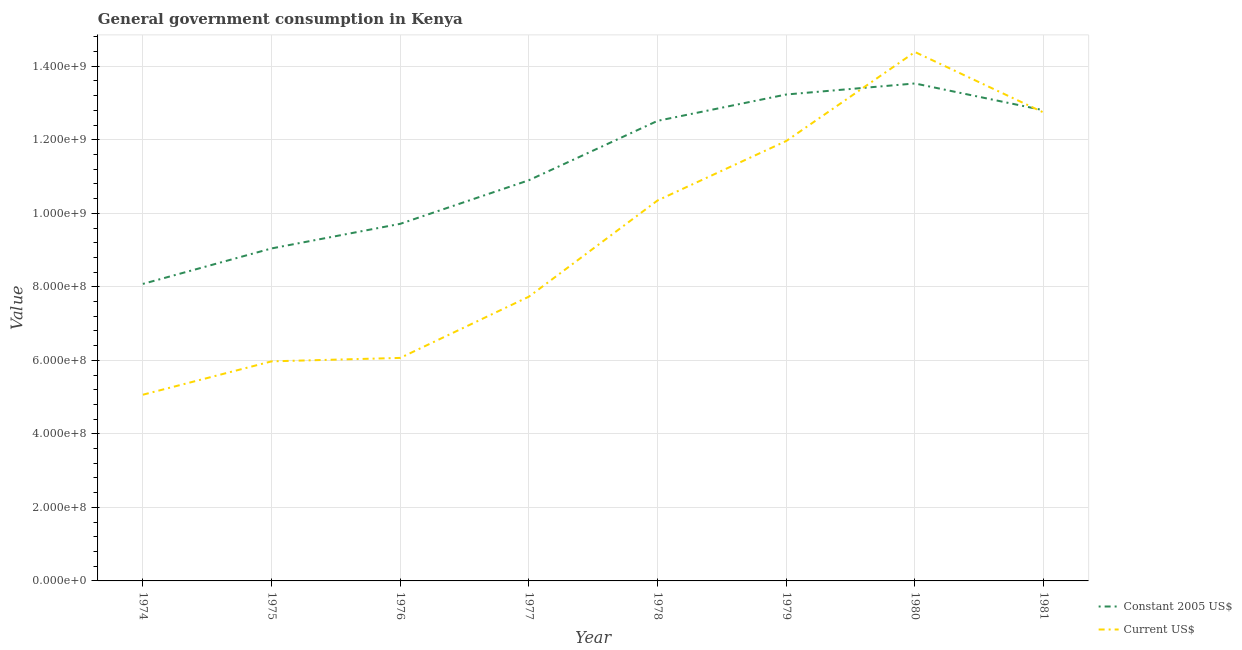Does the line corresponding to value consumed in constant 2005 us$ intersect with the line corresponding to value consumed in current us$?
Your response must be concise. Yes. What is the value consumed in constant 2005 us$ in 1977?
Ensure brevity in your answer.  1.09e+09. Across all years, what is the maximum value consumed in current us$?
Your answer should be compact. 1.44e+09. Across all years, what is the minimum value consumed in current us$?
Your response must be concise. 5.07e+08. In which year was the value consumed in current us$ minimum?
Offer a very short reply. 1974. What is the total value consumed in current us$ in the graph?
Provide a short and direct response. 7.43e+09. What is the difference between the value consumed in constant 2005 us$ in 1977 and that in 1981?
Ensure brevity in your answer.  -1.90e+08. What is the difference between the value consumed in current us$ in 1977 and the value consumed in constant 2005 us$ in 1981?
Provide a succinct answer. -5.07e+08. What is the average value consumed in current us$ per year?
Offer a very short reply. 9.29e+08. In the year 1978, what is the difference between the value consumed in constant 2005 us$ and value consumed in current us$?
Your answer should be very brief. 2.17e+08. What is the ratio of the value consumed in constant 2005 us$ in 1977 to that in 1980?
Provide a short and direct response. 0.81. Is the value consumed in constant 2005 us$ in 1977 less than that in 1979?
Give a very brief answer. Yes. Is the difference between the value consumed in current us$ in 1974 and 1975 greater than the difference between the value consumed in constant 2005 us$ in 1974 and 1975?
Ensure brevity in your answer.  Yes. What is the difference between the highest and the second highest value consumed in constant 2005 us$?
Ensure brevity in your answer.  3.00e+07. What is the difference between the highest and the lowest value consumed in constant 2005 us$?
Offer a very short reply. 5.45e+08. In how many years, is the value consumed in constant 2005 us$ greater than the average value consumed in constant 2005 us$ taken over all years?
Keep it short and to the point. 4. Is the value consumed in current us$ strictly greater than the value consumed in constant 2005 us$ over the years?
Your response must be concise. No. How many years are there in the graph?
Offer a terse response. 8. Where does the legend appear in the graph?
Provide a short and direct response. Bottom right. How many legend labels are there?
Your response must be concise. 2. How are the legend labels stacked?
Your answer should be very brief. Vertical. What is the title of the graph?
Give a very brief answer. General government consumption in Kenya. What is the label or title of the X-axis?
Make the answer very short. Year. What is the label or title of the Y-axis?
Ensure brevity in your answer.  Value. What is the Value of Constant 2005 US$ in 1974?
Offer a very short reply. 8.08e+08. What is the Value of Current US$ in 1974?
Offer a terse response. 5.07e+08. What is the Value of Constant 2005 US$ in 1975?
Offer a very short reply. 9.04e+08. What is the Value in Current US$ in 1975?
Keep it short and to the point. 5.97e+08. What is the Value in Constant 2005 US$ in 1976?
Provide a short and direct response. 9.71e+08. What is the Value in Current US$ in 1976?
Your answer should be very brief. 6.07e+08. What is the Value in Constant 2005 US$ in 1977?
Keep it short and to the point. 1.09e+09. What is the Value of Current US$ in 1977?
Make the answer very short. 7.73e+08. What is the Value in Constant 2005 US$ in 1978?
Your answer should be compact. 1.25e+09. What is the Value in Current US$ in 1978?
Offer a terse response. 1.04e+09. What is the Value of Constant 2005 US$ in 1979?
Provide a short and direct response. 1.32e+09. What is the Value of Current US$ in 1979?
Give a very brief answer. 1.20e+09. What is the Value in Constant 2005 US$ in 1980?
Your answer should be very brief. 1.35e+09. What is the Value of Current US$ in 1980?
Make the answer very short. 1.44e+09. What is the Value of Constant 2005 US$ in 1981?
Offer a terse response. 1.28e+09. What is the Value of Current US$ in 1981?
Offer a very short reply. 1.27e+09. Across all years, what is the maximum Value of Constant 2005 US$?
Offer a terse response. 1.35e+09. Across all years, what is the maximum Value of Current US$?
Provide a short and direct response. 1.44e+09. Across all years, what is the minimum Value in Constant 2005 US$?
Keep it short and to the point. 8.08e+08. Across all years, what is the minimum Value of Current US$?
Ensure brevity in your answer.  5.07e+08. What is the total Value of Constant 2005 US$ in the graph?
Offer a very short reply. 8.98e+09. What is the total Value in Current US$ in the graph?
Your answer should be compact. 7.43e+09. What is the difference between the Value in Constant 2005 US$ in 1974 and that in 1975?
Give a very brief answer. -9.65e+07. What is the difference between the Value of Current US$ in 1974 and that in 1975?
Offer a terse response. -9.08e+07. What is the difference between the Value of Constant 2005 US$ in 1974 and that in 1976?
Your answer should be very brief. -1.63e+08. What is the difference between the Value of Current US$ in 1974 and that in 1976?
Your answer should be very brief. -1.00e+08. What is the difference between the Value of Constant 2005 US$ in 1974 and that in 1977?
Offer a terse response. -2.82e+08. What is the difference between the Value of Current US$ in 1974 and that in 1977?
Give a very brief answer. -2.67e+08. What is the difference between the Value of Constant 2005 US$ in 1974 and that in 1978?
Keep it short and to the point. -4.44e+08. What is the difference between the Value in Current US$ in 1974 and that in 1978?
Ensure brevity in your answer.  -5.28e+08. What is the difference between the Value of Constant 2005 US$ in 1974 and that in 1979?
Keep it short and to the point. -5.15e+08. What is the difference between the Value of Current US$ in 1974 and that in 1979?
Your response must be concise. -6.90e+08. What is the difference between the Value in Constant 2005 US$ in 1974 and that in 1980?
Offer a terse response. -5.45e+08. What is the difference between the Value in Current US$ in 1974 and that in 1980?
Give a very brief answer. -9.32e+08. What is the difference between the Value in Constant 2005 US$ in 1974 and that in 1981?
Offer a terse response. -4.72e+08. What is the difference between the Value of Current US$ in 1974 and that in 1981?
Your answer should be very brief. -7.68e+08. What is the difference between the Value of Constant 2005 US$ in 1975 and that in 1976?
Your response must be concise. -6.69e+07. What is the difference between the Value of Current US$ in 1975 and that in 1976?
Ensure brevity in your answer.  -9.37e+06. What is the difference between the Value in Constant 2005 US$ in 1975 and that in 1977?
Offer a terse response. -1.86e+08. What is the difference between the Value in Current US$ in 1975 and that in 1977?
Ensure brevity in your answer.  -1.76e+08. What is the difference between the Value of Constant 2005 US$ in 1975 and that in 1978?
Offer a terse response. -3.47e+08. What is the difference between the Value in Current US$ in 1975 and that in 1978?
Give a very brief answer. -4.38e+08. What is the difference between the Value of Constant 2005 US$ in 1975 and that in 1979?
Provide a succinct answer. -4.19e+08. What is the difference between the Value of Current US$ in 1975 and that in 1979?
Give a very brief answer. -5.99e+08. What is the difference between the Value in Constant 2005 US$ in 1975 and that in 1980?
Your response must be concise. -4.49e+08. What is the difference between the Value in Current US$ in 1975 and that in 1980?
Your answer should be very brief. -8.41e+08. What is the difference between the Value in Constant 2005 US$ in 1975 and that in 1981?
Make the answer very short. -3.76e+08. What is the difference between the Value in Current US$ in 1975 and that in 1981?
Keep it short and to the point. -6.77e+08. What is the difference between the Value in Constant 2005 US$ in 1976 and that in 1977?
Give a very brief answer. -1.19e+08. What is the difference between the Value of Current US$ in 1976 and that in 1977?
Offer a very short reply. -1.67e+08. What is the difference between the Value of Constant 2005 US$ in 1976 and that in 1978?
Keep it short and to the point. -2.80e+08. What is the difference between the Value in Current US$ in 1976 and that in 1978?
Make the answer very short. -4.28e+08. What is the difference between the Value of Constant 2005 US$ in 1976 and that in 1979?
Your answer should be compact. -3.52e+08. What is the difference between the Value of Current US$ in 1976 and that in 1979?
Ensure brevity in your answer.  -5.90e+08. What is the difference between the Value of Constant 2005 US$ in 1976 and that in 1980?
Make the answer very short. -3.82e+08. What is the difference between the Value in Current US$ in 1976 and that in 1980?
Ensure brevity in your answer.  -8.32e+08. What is the difference between the Value of Constant 2005 US$ in 1976 and that in 1981?
Provide a succinct answer. -3.09e+08. What is the difference between the Value in Current US$ in 1976 and that in 1981?
Your answer should be compact. -6.68e+08. What is the difference between the Value of Constant 2005 US$ in 1977 and that in 1978?
Provide a short and direct response. -1.62e+08. What is the difference between the Value of Current US$ in 1977 and that in 1978?
Give a very brief answer. -2.62e+08. What is the difference between the Value in Constant 2005 US$ in 1977 and that in 1979?
Your answer should be very brief. -2.33e+08. What is the difference between the Value in Current US$ in 1977 and that in 1979?
Your response must be concise. -4.23e+08. What is the difference between the Value in Constant 2005 US$ in 1977 and that in 1980?
Keep it short and to the point. -2.63e+08. What is the difference between the Value of Current US$ in 1977 and that in 1980?
Keep it short and to the point. -6.66e+08. What is the difference between the Value in Constant 2005 US$ in 1977 and that in 1981?
Your answer should be compact. -1.90e+08. What is the difference between the Value in Current US$ in 1977 and that in 1981?
Ensure brevity in your answer.  -5.01e+08. What is the difference between the Value of Constant 2005 US$ in 1978 and that in 1979?
Your answer should be compact. -7.16e+07. What is the difference between the Value in Current US$ in 1978 and that in 1979?
Offer a terse response. -1.62e+08. What is the difference between the Value in Constant 2005 US$ in 1978 and that in 1980?
Keep it short and to the point. -1.02e+08. What is the difference between the Value of Current US$ in 1978 and that in 1980?
Your answer should be compact. -4.04e+08. What is the difference between the Value in Constant 2005 US$ in 1978 and that in 1981?
Your response must be concise. -2.88e+07. What is the difference between the Value of Current US$ in 1978 and that in 1981?
Your answer should be compact. -2.39e+08. What is the difference between the Value in Constant 2005 US$ in 1979 and that in 1980?
Your answer should be compact. -3.00e+07. What is the difference between the Value of Current US$ in 1979 and that in 1980?
Offer a very short reply. -2.42e+08. What is the difference between the Value in Constant 2005 US$ in 1979 and that in 1981?
Offer a terse response. 4.29e+07. What is the difference between the Value in Current US$ in 1979 and that in 1981?
Keep it short and to the point. -7.74e+07. What is the difference between the Value of Constant 2005 US$ in 1980 and that in 1981?
Offer a terse response. 7.29e+07. What is the difference between the Value in Current US$ in 1980 and that in 1981?
Make the answer very short. 1.65e+08. What is the difference between the Value in Constant 2005 US$ in 1974 and the Value in Current US$ in 1975?
Offer a terse response. 2.11e+08. What is the difference between the Value of Constant 2005 US$ in 1974 and the Value of Current US$ in 1976?
Your response must be concise. 2.01e+08. What is the difference between the Value of Constant 2005 US$ in 1974 and the Value of Current US$ in 1977?
Your answer should be very brief. 3.47e+07. What is the difference between the Value in Constant 2005 US$ in 1974 and the Value in Current US$ in 1978?
Offer a terse response. -2.27e+08. What is the difference between the Value of Constant 2005 US$ in 1974 and the Value of Current US$ in 1979?
Make the answer very short. -3.89e+08. What is the difference between the Value of Constant 2005 US$ in 1974 and the Value of Current US$ in 1980?
Give a very brief answer. -6.31e+08. What is the difference between the Value of Constant 2005 US$ in 1974 and the Value of Current US$ in 1981?
Ensure brevity in your answer.  -4.66e+08. What is the difference between the Value of Constant 2005 US$ in 1975 and the Value of Current US$ in 1976?
Your answer should be very brief. 2.98e+08. What is the difference between the Value of Constant 2005 US$ in 1975 and the Value of Current US$ in 1977?
Give a very brief answer. 1.31e+08. What is the difference between the Value in Constant 2005 US$ in 1975 and the Value in Current US$ in 1978?
Your response must be concise. -1.31e+08. What is the difference between the Value in Constant 2005 US$ in 1975 and the Value in Current US$ in 1979?
Provide a short and direct response. -2.92e+08. What is the difference between the Value in Constant 2005 US$ in 1975 and the Value in Current US$ in 1980?
Your answer should be compact. -5.34e+08. What is the difference between the Value of Constant 2005 US$ in 1975 and the Value of Current US$ in 1981?
Provide a short and direct response. -3.70e+08. What is the difference between the Value of Constant 2005 US$ in 1976 and the Value of Current US$ in 1977?
Keep it short and to the point. 1.98e+08. What is the difference between the Value in Constant 2005 US$ in 1976 and the Value in Current US$ in 1978?
Offer a very short reply. -6.36e+07. What is the difference between the Value of Constant 2005 US$ in 1976 and the Value of Current US$ in 1979?
Provide a succinct answer. -2.25e+08. What is the difference between the Value of Constant 2005 US$ in 1976 and the Value of Current US$ in 1980?
Your answer should be compact. -4.67e+08. What is the difference between the Value of Constant 2005 US$ in 1976 and the Value of Current US$ in 1981?
Make the answer very short. -3.03e+08. What is the difference between the Value in Constant 2005 US$ in 1977 and the Value in Current US$ in 1978?
Provide a succinct answer. 5.50e+07. What is the difference between the Value of Constant 2005 US$ in 1977 and the Value of Current US$ in 1979?
Your answer should be compact. -1.07e+08. What is the difference between the Value of Constant 2005 US$ in 1977 and the Value of Current US$ in 1980?
Offer a terse response. -3.49e+08. What is the difference between the Value of Constant 2005 US$ in 1977 and the Value of Current US$ in 1981?
Your response must be concise. -1.84e+08. What is the difference between the Value of Constant 2005 US$ in 1978 and the Value of Current US$ in 1979?
Offer a terse response. 5.48e+07. What is the difference between the Value of Constant 2005 US$ in 1978 and the Value of Current US$ in 1980?
Keep it short and to the point. -1.87e+08. What is the difference between the Value of Constant 2005 US$ in 1978 and the Value of Current US$ in 1981?
Ensure brevity in your answer.  -2.26e+07. What is the difference between the Value in Constant 2005 US$ in 1979 and the Value in Current US$ in 1980?
Ensure brevity in your answer.  -1.16e+08. What is the difference between the Value of Constant 2005 US$ in 1979 and the Value of Current US$ in 1981?
Provide a succinct answer. 4.90e+07. What is the difference between the Value of Constant 2005 US$ in 1980 and the Value of Current US$ in 1981?
Offer a terse response. 7.90e+07. What is the average Value in Constant 2005 US$ per year?
Your answer should be compact. 1.12e+09. What is the average Value in Current US$ per year?
Your answer should be very brief. 9.29e+08. In the year 1974, what is the difference between the Value in Constant 2005 US$ and Value in Current US$?
Offer a terse response. 3.01e+08. In the year 1975, what is the difference between the Value of Constant 2005 US$ and Value of Current US$?
Ensure brevity in your answer.  3.07e+08. In the year 1976, what is the difference between the Value of Constant 2005 US$ and Value of Current US$?
Offer a terse response. 3.65e+08. In the year 1977, what is the difference between the Value in Constant 2005 US$ and Value in Current US$?
Your response must be concise. 3.17e+08. In the year 1978, what is the difference between the Value of Constant 2005 US$ and Value of Current US$?
Make the answer very short. 2.17e+08. In the year 1979, what is the difference between the Value of Constant 2005 US$ and Value of Current US$?
Keep it short and to the point. 1.26e+08. In the year 1980, what is the difference between the Value of Constant 2005 US$ and Value of Current US$?
Your response must be concise. -8.56e+07. In the year 1981, what is the difference between the Value in Constant 2005 US$ and Value in Current US$?
Offer a very short reply. 6.19e+06. What is the ratio of the Value of Constant 2005 US$ in 1974 to that in 1975?
Ensure brevity in your answer.  0.89. What is the ratio of the Value in Current US$ in 1974 to that in 1975?
Your answer should be very brief. 0.85. What is the ratio of the Value of Constant 2005 US$ in 1974 to that in 1976?
Your answer should be very brief. 0.83. What is the ratio of the Value in Current US$ in 1974 to that in 1976?
Make the answer very short. 0.83. What is the ratio of the Value of Constant 2005 US$ in 1974 to that in 1977?
Keep it short and to the point. 0.74. What is the ratio of the Value in Current US$ in 1974 to that in 1977?
Your answer should be compact. 0.66. What is the ratio of the Value of Constant 2005 US$ in 1974 to that in 1978?
Keep it short and to the point. 0.65. What is the ratio of the Value in Current US$ in 1974 to that in 1978?
Offer a very short reply. 0.49. What is the ratio of the Value in Constant 2005 US$ in 1974 to that in 1979?
Offer a very short reply. 0.61. What is the ratio of the Value in Current US$ in 1974 to that in 1979?
Your answer should be very brief. 0.42. What is the ratio of the Value in Constant 2005 US$ in 1974 to that in 1980?
Ensure brevity in your answer.  0.6. What is the ratio of the Value in Current US$ in 1974 to that in 1980?
Provide a succinct answer. 0.35. What is the ratio of the Value in Constant 2005 US$ in 1974 to that in 1981?
Offer a terse response. 0.63. What is the ratio of the Value in Current US$ in 1974 to that in 1981?
Your response must be concise. 0.4. What is the ratio of the Value in Constant 2005 US$ in 1975 to that in 1976?
Offer a very short reply. 0.93. What is the ratio of the Value of Current US$ in 1975 to that in 1976?
Give a very brief answer. 0.98. What is the ratio of the Value of Constant 2005 US$ in 1975 to that in 1977?
Give a very brief answer. 0.83. What is the ratio of the Value of Current US$ in 1975 to that in 1977?
Provide a succinct answer. 0.77. What is the ratio of the Value in Constant 2005 US$ in 1975 to that in 1978?
Offer a very short reply. 0.72. What is the ratio of the Value in Current US$ in 1975 to that in 1978?
Ensure brevity in your answer.  0.58. What is the ratio of the Value of Constant 2005 US$ in 1975 to that in 1979?
Your response must be concise. 0.68. What is the ratio of the Value of Current US$ in 1975 to that in 1979?
Ensure brevity in your answer.  0.5. What is the ratio of the Value in Constant 2005 US$ in 1975 to that in 1980?
Give a very brief answer. 0.67. What is the ratio of the Value in Current US$ in 1975 to that in 1980?
Ensure brevity in your answer.  0.42. What is the ratio of the Value in Constant 2005 US$ in 1975 to that in 1981?
Keep it short and to the point. 0.71. What is the ratio of the Value in Current US$ in 1975 to that in 1981?
Keep it short and to the point. 0.47. What is the ratio of the Value of Constant 2005 US$ in 1976 to that in 1977?
Your answer should be very brief. 0.89. What is the ratio of the Value of Current US$ in 1976 to that in 1977?
Offer a very short reply. 0.78. What is the ratio of the Value of Constant 2005 US$ in 1976 to that in 1978?
Provide a short and direct response. 0.78. What is the ratio of the Value in Current US$ in 1976 to that in 1978?
Your answer should be very brief. 0.59. What is the ratio of the Value of Constant 2005 US$ in 1976 to that in 1979?
Your answer should be compact. 0.73. What is the ratio of the Value of Current US$ in 1976 to that in 1979?
Your answer should be very brief. 0.51. What is the ratio of the Value in Constant 2005 US$ in 1976 to that in 1980?
Make the answer very short. 0.72. What is the ratio of the Value of Current US$ in 1976 to that in 1980?
Make the answer very short. 0.42. What is the ratio of the Value of Constant 2005 US$ in 1976 to that in 1981?
Offer a terse response. 0.76. What is the ratio of the Value of Current US$ in 1976 to that in 1981?
Your answer should be very brief. 0.48. What is the ratio of the Value of Constant 2005 US$ in 1977 to that in 1978?
Ensure brevity in your answer.  0.87. What is the ratio of the Value of Current US$ in 1977 to that in 1978?
Keep it short and to the point. 0.75. What is the ratio of the Value of Constant 2005 US$ in 1977 to that in 1979?
Provide a succinct answer. 0.82. What is the ratio of the Value of Current US$ in 1977 to that in 1979?
Keep it short and to the point. 0.65. What is the ratio of the Value of Constant 2005 US$ in 1977 to that in 1980?
Provide a short and direct response. 0.81. What is the ratio of the Value in Current US$ in 1977 to that in 1980?
Your answer should be very brief. 0.54. What is the ratio of the Value in Constant 2005 US$ in 1977 to that in 1981?
Your answer should be very brief. 0.85. What is the ratio of the Value of Current US$ in 1977 to that in 1981?
Give a very brief answer. 0.61. What is the ratio of the Value of Constant 2005 US$ in 1978 to that in 1979?
Give a very brief answer. 0.95. What is the ratio of the Value of Current US$ in 1978 to that in 1979?
Make the answer very short. 0.86. What is the ratio of the Value in Constant 2005 US$ in 1978 to that in 1980?
Your answer should be very brief. 0.92. What is the ratio of the Value in Current US$ in 1978 to that in 1980?
Provide a succinct answer. 0.72. What is the ratio of the Value of Constant 2005 US$ in 1978 to that in 1981?
Offer a very short reply. 0.98. What is the ratio of the Value of Current US$ in 1978 to that in 1981?
Make the answer very short. 0.81. What is the ratio of the Value of Constant 2005 US$ in 1979 to that in 1980?
Provide a short and direct response. 0.98. What is the ratio of the Value of Current US$ in 1979 to that in 1980?
Your answer should be very brief. 0.83. What is the ratio of the Value in Constant 2005 US$ in 1979 to that in 1981?
Give a very brief answer. 1.03. What is the ratio of the Value in Current US$ in 1979 to that in 1981?
Offer a very short reply. 0.94. What is the ratio of the Value in Constant 2005 US$ in 1980 to that in 1981?
Your response must be concise. 1.06. What is the ratio of the Value in Current US$ in 1980 to that in 1981?
Make the answer very short. 1.13. What is the difference between the highest and the second highest Value in Constant 2005 US$?
Ensure brevity in your answer.  3.00e+07. What is the difference between the highest and the second highest Value of Current US$?
Make the answer very short. 1.65e+08. What is the difference between the highest and the lowest Value of Constant 2005 US$?
Keep it short and to the point. 5.45e+08. What is the difference between the highest and the lowest Value in Current US$?
Make the answer very short. 9.32e+08. 